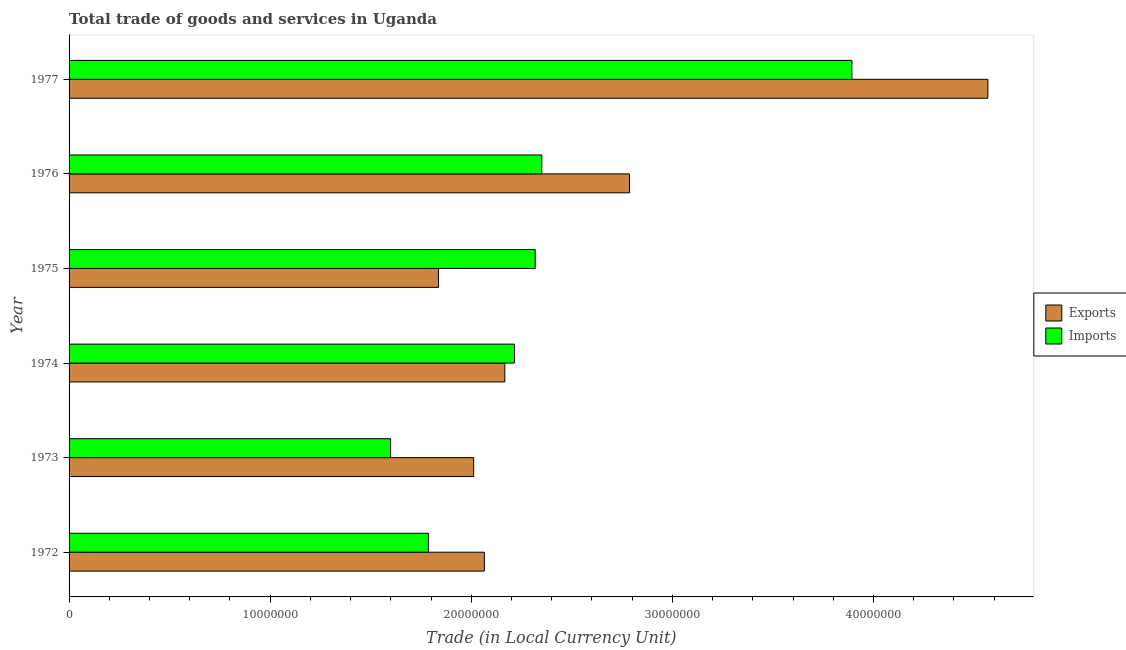How many different coloured bars are there?
Ensure brevity in your answer.  2. What is the label of the 4th group of bars from the top?
Ensure brevity in your answer.  1974. In how many cases, is the number of bars for a given year not equal to the number of legend labels?
Give a very brief answer. 0. What is the export of goods and services in 1977?
Provide a succinct answer. 4.57e+07. Across all years, what is the maximum export of goods and services?
Your answer should be very brief. 4.57e+07. Across all years, what is the minimum imports of goods and services?
Your answer should be very brief. 1.60e+07. In which year was the export of goods and services maximum?
Give a very brief answer. 1977. In which year was the imports of goods and services minimum?
Offer a very short reply. 1973. What is the total imports of goods and services in the graph?
Provide a short and direct response. 1.42e+08. What is the difference between the export of goods and services in 1975 and that in 1976?
Your response must be concise. -9.50e+06. What is the difference between the imports of goods and services in 1977 and the export of goods and services in 1973?
Your response must be concise. 1.88e+07. What is the average export of goods and services per year?
Offer a terse response. 2.57e+07. In the year 1974, what is the difference between the export of goods and services and imports of goods and services?
Provide a short and direct response. -4.80e+05. What is the ratio of the imports of goods and services in 1975 to that in 1977?
Your answer should be very brief. 0.59. Is the imports of goods and services in 1974 less than that in 1975?
Your answer should be compact. Yes. Is the difference between the imports of goods and services in 1973 and 1975 greater than the difference between the export of goods and services in 1973 and 1975?
Your answer should be compact. No. What is the difference between the highest and the second highest export of goods and services?
Make the answer very short. 1.78e+07. What is the difference between the highest and the lowest imports of goods and services?
Your answer should be very brief. 2.29e+07. What does the 2nd bar from the top in 1975 represents?
Your answer should be compact. Exports. What does the 2nd bar from the bottom in 1975 represents?
Your answer should be very brief. Imports. How many bars are there?
Offer a very short reply. 12. How many years are there in the graph?
Give a very brief answer. 6. What is the difference between two consecutive major ticks on the X-axis?
Provide a short and direct response. 1.00e+07. Does the graph contain grids?
Give a very brief answer. No. How are the legend labels stacked?
Provide a succinct answer. Vertical. What is the title of the graph?
Offer a very short reply. Total trade of goods and services in Uganda. Does "Girls" appear as one of the legend labels in the graph?
Provide a short and direct response. No. What is the label or title of the X-axis?
Provide a short and direct response. Trade (in Local Currency Unit). What is the Trade (in Local Currency Unit) in Exports in 1972?
Your answer should be very brief. 2.06e+07. What is the Trade (in Local Currency Unit) of Imports in 1972?
Your response must be concise. 1.79e+07. What is the Trade (in Local Currency Unit) of Exports in 1973?
Ensure brevity in your answer.  2.01e+07. What is the Trade (in Local Currency Unit) of Imports in 1973?
Make the answer very short. 1.60e+07. What is the Trade (in Local Currency Unit) of Exports in 1974?
Your answer should be very brief. 2.17e+07. What is the Trade (in Local Currency Unit) of Imports in 1974?
Offer a very short reply. 2.22e+07. What is the Trade (in Local Currency Unit) in Exports in 1975?
Keep it short and to the point. 1.84e+07. What is the Trade (in Local Currency Unit) of Imports in 1975?
Your answer should be compact. 2.32e+07. What is the Trade (in Local Currency Unit) in Exports in 1976?
Give a very brief answer. 2.79e+07. What is the Trade (in Local Currency Unit) in Imports in 1976?
Your response must be concise. 2.35e+07. What is the Trade (in Local Currency Unit) in Exports in 1977?
Your response must be concise. 4.57e+07. What is the Trade (in Local Currency Unit) of Imports in 1977?
Make the answer very short. 3.89e+07. Across all years, what is the maximum Trade (in Local Currency Unit) of Exports?
Provide a succinct answer. 4.57e+07. Across all years, what is the maximum Trade (in Local Currency Unit) in Imports?
Ensure brevity in your answer.  3.89e+07. Across all years, what is the minimum Trade (in Local Currency Unit) of Exports?
Ensure brevity in your answer.  1.84e+07. Across all years, what is the minimum Trade (in Local Currency Unit) in Imports?
Your response must be concise. 1.60e+07. What is the total Trade (in Local Currency Unit) of Exports in the graph?
Provide a succinct answer. 1.54e+08. What is the total Trade (in Local Currency Unit) in Imports in the graph?
Ensure brevity in your answer.  1.42e+08. What is the difference between the Trade (in Local Currency Unit) of Exports in 1972 and that in 1973?
Offer a very short reply. 5.30e+05. What is the difference between the Trade (in Local Currency Unit) in Imports in 1972 and that in 1973?
Keep it short and to the point. 1.88e+06. What is the difference between the Trade (in Local Currency Unit) in Exports in 1972 and that in 1974?
Make the answer very short. -1.02e+06. What is the difference between the Trade (in Local Currency Unit) of Imports in 1972 and that in 1974?
Keep it short and to the point. -4.28e+06. What is the difference between the Trade (in Local Currency Unit) of Exports in 1972 and that in 1975?
Your response must be concise. 2.28e+06. What is the difference between the Trade (in Local Currency Unit) in Imports in 1972 and that in 1975?
Offer a terse response. -5.31e+06. What is the difference between the Trade (in Local Currency Unit) in Exports in 1972 and that in 1976?
Your answer should be compact. -7.22e+06. What is the difference between the Trade (in Local Currency Unit) of Imports in 1972 and that in 1976?
Offer a very short reply. -5.64e+06. What is the difference between the Trade (in Local Currency Unit) in Exports in 1972 and that in 1977?
Ensure brevity in your answer.  -2.50e+07. What is the difference between the Trade (in Local Currency Unit) of Imports in 1972 and that in 1977?
Offer a very short reply. -2.11e+07. What is the difference between the Trade (in Local Currency Unit) of Exports in 1973 and that in 1974?
Your response must be concise. -1.55e+06. What is the difference between the Trade (in Local Currency Unit) of Imports in 1973 and that in 1974?
Ensure brevity in your answer.  -6.16e+06. What is the difference between the Trade (in Local Currency Unit) of Exports in 1973 and that in 1975?
Provide a short and direct response. 1.75e+06. What is the difference between the Trade (in Local Currency Unit) in Imports in 1973 and that in 1975?
Give a very brief answer. -7.19e+06. What is the difference between the Trade (in Local Currency Unit) in Exports in 1973 and that in 1976?
Offer a very short reply. -7.75e+06. What is the difference between the Trade (in Local Currency Unit) of Imports in 1973 and that in 1976?
Give a very brief answer. -7.52e+06. What is the difference between the Trade (in Local Currency Unit) of Exports in 1973 and that in 1977?
Keep it short and to the point. -2.56e+07. What is the difference between the Trade (in Local Currency Unit) in Imports in 1973 and that in 1977?
Your answer should be very brief. -2.29e+07. What is the difference between the Trade (in Local Currency Unit) of Exports in 1974 and that in 1975?
Your answer should be very brief. 3.30e+06. What is the difference between the Trade (in Local Currency Unit) in Imports in 1974 and that in 1975?
Ensure brevity in your answer.  -1.03e+06. What is the difference between the Trade (in Local Currency Unit) of Exports in 1974 and that in 1976?
Offer a very short reply. -6.20e+06. What is the difference between the Trade (in Local Currency Unit) of Imports in 1974 and that in 1976?
Make the answer very short. -1.36e+06. What is the difference between the Trade (in Local Currency Unit) of Exports in 1974 and that in 1977?
Your answer should be compact. -2.40e+07. What is the difference between the Trade (in Local Currency Unit) of Imports in 1974 and that in 1977?
Your response must be concise. -1.68e+07. What is the difference between the Trade (in Local Currency Unit) in Exports in 1975 and that in 1976?
Give a very brief answer. -9.50e+06. What is the difference between the Trade (in Local Currency Unit) of Imports in 1975 and that in 1976?
Give a very brief answer. -3.30e+05. What is the difference between the Trade (in Local Currency Unit) in Exports in 1975 and that in 1977?
Give a very brief answer. -2.73e+07. What is the difference between the Trade (in Local Currency Unit) in Imports in 1975 and that in 1977?
Your answer should be very brief. -1.58e+07. What is the difference between the Trade (in Local Currency Unit) of Exports in 1976 and that in 1977?
Offer a terse response. -1.78e+07. What is the difference between the Trade (in Local Currency Unit) of Imports in 1976 and that in 1977?
Provide a succinct answer. -1.54e+07. What is the difference between the Trade (in Local Currency Unit) in Exports in 1972 and the Trade (in Local Currency Unit) in Imports in 1973?
Give a very brief answer. 4.66e+06. What is the difference between the Trade (in Local Currency Unit) of Exports in 1972 and the Trade (in Local Currency Unit) of Imports in 1974?
Your response must be concise. -1.50e+06. What is the difference between the Trade (in Local Currency Unit) of Exports in 1972 and the Trade (in Local Currency Unit) of Imports in 1975?
Your answer should be very brief. -2.53e+06. What is the difference between the Trade (in Local Currency Unit) of Exports in 1972 and the Trade (in Local Currency Unit) of Imports in 1976?
Offer a terse response. -2.86e+06. What is the difference between the Trade (in Local Currency Unit) of Exports in 1972 and the Trade (in Local Currency Unit) of Imports in 1977?
Offer a terse response. -1.83e+07. What is the difference between the Trade (in Local Currency Unit) in Exports in 1973 and the Trade (in Local Currency Unit) in Imports in 1974?
Your answer should be very brief. -2.03e+06. What is the difference between the Trade (in Local Currency Unit) of Exports in 1973 and the Trade (in Local Currency Unit) of Imports in 1975?
Provide a short and direct response. -3.06e+06. What is the difference between the Trade (in Local Currency Unit) of Exports in 1973 and the Trade (in Local Currency Unit) of Imports in 1976?
Give a very brief answer. -3.39e+06. What is the difference between the Trade (in Local Currency Unit) of Exports in 1973 and the Trade (in Local Currency Unit) of Imports in 1977?
Provide a succinct answer. -1.88e+07. What is the difference between the Trade (in Local Currency Unit) of Exports in 1974 and the Trade (in Local Currency Unit) of Imports in 1975?
Make the answer very short. -1.51e+06. What is the difference between the Trade (in Local Currency Unit) in Exports in 1974 and the Trade (in Local Currency Unit) in Imports in 1976?
Provide a succinct answer. -1.84e+06. What is the difference between the Trade (in Local Currency Unit) in Exports in 1974 and the Trade (in Local Currency Unit) in Imports in 1977?
Keep it short and to the point. -1.73e+07. What is the difference between the Trade (in Local Currency Unit) of Exports in 1975 and the Trade (in Local Currency Unit) of Imports in 1976?
Give a very brief answer. -5.14e+06. What is the difference between the Trade (in Local Currency Unit) of Exports in 1975 and the Trade (in Local Currency Unit) of Imports in 1977?
Your response must be concise. -2.06e+07. What is the difference between the Trade (in Local Currency Unit) in Exports in 1976 and the Trade (in Local Currency Unit) in Imports in 1977?
Your answer should be compact. -1.11e+07. What is the average Trade (in Local Currency Unit) of Exports per year?
Offer a terse response. 2.57e+07. What is the average Trade (in Local Currency Unit) in Imports per year?
Your answer should be compact. 2.36e+07. In the year 1972, what is the difference between the Trade (in Local Currency Unit) of Exports and Trade (in Local Currency Unit) of Imports?
Make the answer very short. 2.78e+06. In the year 1973, what is the difference between the Trade (in Local Currency Unit) of Exports and Trade (in Local Currency Unit) of Imports?
Your answer should be very brief. 4.13e+06. In the year 1974, what is the difference between the Trade (in Local Currency Unit) in Exports and Trade (in Local Currency Unit) in Imports?
Offer a very short reply. -4.80e+05. In the year 1975, what is the difference between the Trade (in Local Currency Unit) in Exports and Trade (in Local Currency Unit) in Imports?
Make the answer very short. -4.81e+06. In the year 1976, what is the difference between the Trade (in Local Currency Unit) in Exports and Trade (in Local Currency Unit) in Imports?
Ensure brevity in your answer.  4.36e+06. In the year 1977, what is the difference between the Trade (in Local Currency Unit) in Exports and Trade (in Local Currency Unit) in Imports?
Your answer should be compact. 6.76e+06. What is the ratio of the Trade (in Local Currency Unit) of Exports in 1972 to that in 1973?
Provide a short and direct response. 1.03. What is the ratio of the Trade (in Local Currency Unit) in Imports in 1972 to that in 1973?
Ensure brevity in your answer.  1.12. What is the ratio of the Trade (in Local Currency Unit) in Exports in 1972 to that in 1974?
Your answer should be very brief. 0.95. What is the ratio of the Trade (in Local Currency Unit) in Imports in 1972 to that in 1974?
Ensure brevity in your answer.  0.81. What is the ratio of the Trade (in Local Currency Unit) in Exports in 1972 to that in 1975?
Your response must be concise. 1.12. What is the ratio of the Trade (in Local Currency Unit) in Imports in 1972 to that in 1975?
Your answer should be compact. 0.77. What is the ratio of the Trade (in Local Currency Unit) in Exports in 1972 to that in 1976?
Keep it short and to the point. 0.74. What is the ratio of the Trade (in Local Currency Unit) in Imports in 1972 to that in 1976?
Your answer should be compact. 0.76. What is the ratio of the Trade (in Local Currency Unit) of Exports in 1972 to that in 1977?
Your answer should be very brief. 0.45. What is the ratio of the Trade (in Local Currency Unit) of Imports in 1972 to that in 1977?
Offer a very short reply. 0.46. What is the ratio of the Trade (in Local Currency Unit) of Exports in 1973 to that in 1974?
Your answer should be compact. 0.93. What is the ratio of the Trade (in Local Currency Unit) in Imports in 1973 to that in 1974?
Your answer should be compact. 0.72. What is the ratio of the Trade (in Local Currency Unit) in Exports in 1973 to that in 1975?
Provide a succinct answer. 1.1. What is the ratio of the Trade (in Local Currency Unit) of Imports in 1973 to that in 1975?
Offer a terse response. 0.69. What is the ratio of the Trade (in Local Currency Unit) of Exports in 1973 to that in 1976?
Your response must be concise. 0.72. What is the ratio of the Trade (in Local Currency Unit) of Imports in 1973 to that in 1976?
Provide a short and direct response. 0.68. What is the ratio of the Trade (in Local Currency Unit) in Exports in 1973 to that in 1977?
Your answer should be compact. 0.44. What is the ratio of the Trade (in Local Currency Unit) of Imports in 1973 to that in 1977?
Offer a terse response. 0.41. What is the ratio of the Trade (in Local Currency Unit) of Exports in 1974 to that in 1975?
Provide a short and direct response. 1.18. What is the ratio of the Trade (in Local Currency Unit) in Imports in 1974 to that in 1975?
Offer a terse response. 0.96. What is the ratio of the Trade (in Local Currency Unit) in Exports in 1974 to that in 1976?
Your answer should be compact. 0.78. What is the ratio of the Trade (in Local Currency Unit) of Imports in 1974 to that in 1976?
Your answer should be compact. 0.94. What is the ratio of the Trade (in Local Currency Unit) of Exports in 1974 to that in 1977?
Keep it short and to the point. 0.47. What is the ratio of the Trade (in Local Currency Unit) of Imports in 1974 to that in 1977?
Offer a very short reply. 0.57. What is the ratio of the Trade (in Local Currency Unit) of Exports in 1975 to that in 1976?
Offer a very short reply. 0.66. What is the ratio of the Trade (in Local Currency Unit) in Imports in 1975 to that in 1976?
Make the answer very short. 0.99. What is the ratio of the Trade (in Local Currency Unit) of Exports in 1975 to that in 1977?
Ensure brevity in your answer.  0.4. What is the ratio of the Trade (in Local Currency Unit) in Imports in 1975 to that in 1977?
Give a very brief answer. 0.6. What is the ratio of the Trade (in Local Currency Unit) in Exports in 1976 to that in 1977?
Ensure brevity in your answer.  0.61. What is the ratio of the Trade (in Local Currency Unit) in Imports in 1976 to that in 1977?
Make the answer very short. 0.6. What is the difference between the highest and the second highest Trade (in Local Currency Unit) in Exports?
Offer a terse response. 1.78e+07. What is the difference between the highest and the second highest Trade (in Local Currency Unit) in Imports?
Your answer should be very brief. 1.54e+07. What is the difference between the highest and the lowest Trade (in Local Currency Unit) in Exports?
Offer a very short reply. 2.73e+07. What is the difference between the highest and the lowest Trade (in Local Currency Unit) of Imports?
Provide a short and direct response. 2.29e+07. 